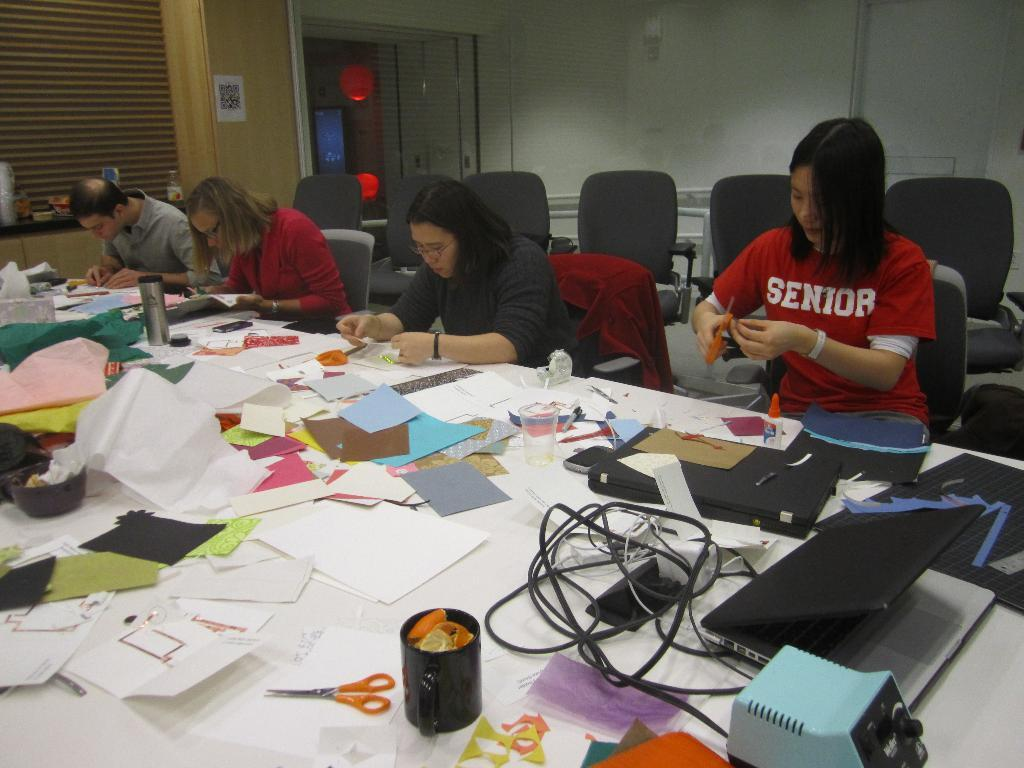<image>
Relay a brief, clear account of the picture shown. Two kids working on a project, one is wearing a senior shirt 